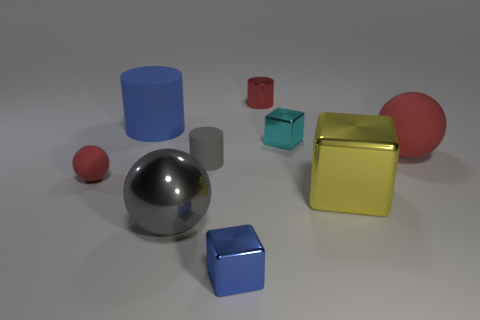Subtract all cubes. How many objects are left? 6 Add 1 small red spheres. How many objects exist? 10 Subtract all small gray rubber cylinders. Subtract all red balls. How many objects are left? 6 Add 4 balls. How many balls are left? 7 Add 8 big yellow cubes. How many big yellow cubes exist? 9 Subtract 0 brown blocks. How many objects are left? 9 